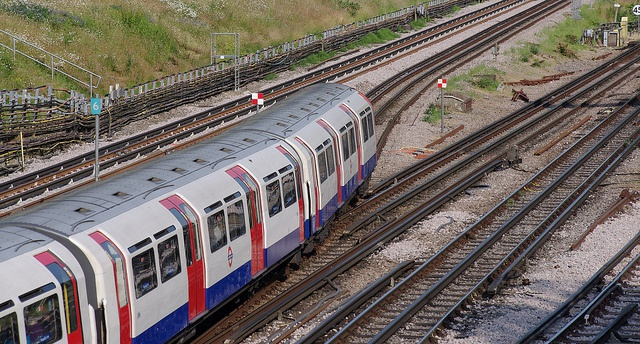Describe the objects in this image and their specific colors. I can see a train in olive, darkgray, lightgray, gray, and black tones in this image. 